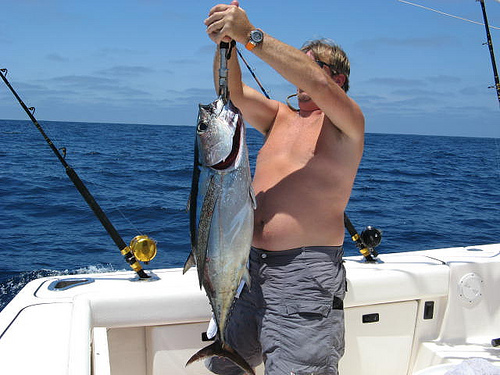<image>
Is there a man on the fish? No. The man is not positioned on the fish. They may be near each other, but the man is not supported by or resting on top of the fish. Is there a fish behind the man? No. The fish is not behind the man. From this viewpoint, the fish appears to be positioned elsewhere in the scene. 